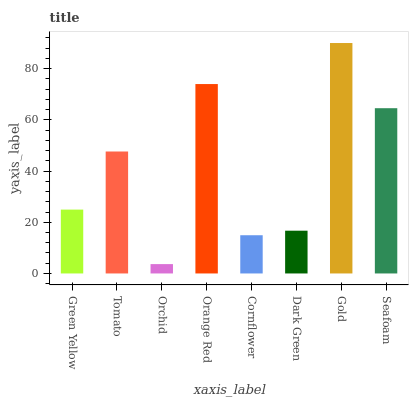Is Orchid the minimum?
Answer yes or no. Yes. Is Gold the maximum?
Answer yes or no. Yes. Is Tomato the minimum?
Answer yes or no. No. Is Tomato the maximum?
Answer yes or no. No. Is Tomato greater than Green Yellow?
Answer yes or no. Yes. Is Green Yellow less than Tomato?
Answer yes or no. Yes. Is Green Yellow greater than Tomato?
Answer yes or no. No. Is Tomato less than Green Yellow?
Answer yes or no. No. Is Tomato the high median?
Answer yes or no. Yes. Is Green Yellow the low median?
Answer yes or no. Yes. Is Green Yellow the high median?
Answer yes or no. No. Is Orchid the low median?
Answer yes or no. No. 